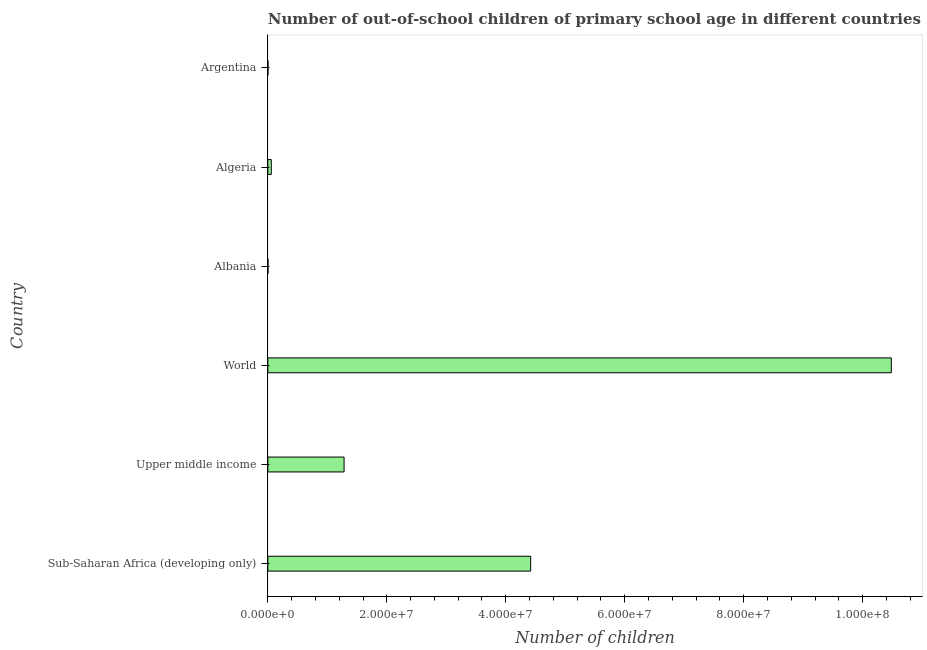What is the title of the graph?
Your answer should be compact. Number of out-of-school children of primary school age in different countries. What is the label or title of the X-axis?
Ensure brevity in your answer.  Number of children. What is the label or title of the Y-axis?
Provide a short and direct response. Country. What is the number of out-of-school children in Albania?
Offer a terse response. 1.99e+04. Across all countries, what is the maximum number of out-of-school children?
Offer a terse response. 1.05e+08. Across all countries, what is the minimum number of out-of-school children?
Your response must be concise. 1.99e+04. In which country was the number of out-of-school children maximum?
Offer a terse response. World. In which country was the number of out-of-school children minimum?
Provide a short and direct response. Albania. What is the sum of the number of out-of-school children?
Your response must be concise. 1.62e+08. What is the difference between the number of out-of-school children in Sub-Saharan Africa (developing only) and Upper middle income?
Keep it short and to the point. 3.14e+07. What is the average number of out-of-school children per country?
Keep it short and to the point. 2.71e+07. What is the median number of out-of-school children?
Provide a short and direct response. 6.70e+06. What is the ratio of the number of out-of-school children in Argentina to that in World?
Keep it short and to the point. 0. Is the difference between the number of out-of-school children in Sub-Saharan Africa (developing only) and Upper middle income greater than the difference between any two countries?
Your response must be concise. No. What is the difference between the highest and the second highest number of out-of-school children?
Ensure brevity in your answer.  6.06e+07. What is the difference between the highest and the lowest number of out-of-school children?
Offer a very short reply. 1.05e+08. In how many countries, is the number of out-of-school children greater than the average number of out-of-school children taken over all countries?
Your response must be concise. 2. How many countries are there in the graph?
Your answer should be compact. 6. Are the values on the major ticks of X-axis written in scientific E-notation?
Provide a succinct answer. Yes. What is the Number of children of Sub-Saharan Africa (developing only)?
Make the answer very short. 4.42e+07. What is the Number of children of Upper middle income?
Give a very brief answer. 1.28e+07. What is the Number of children in World?
Make the answer very short. 1.05e+08. What is the Number of children in Albania?
Your answer should be compact. 1.99e+04. What is the Number of children of Algeria?
Keep it short and to the point. 5.78e+05. What is the Number of children of Argentina?
Keep it short and to the point. 2.34e+04. What is the difference between the Number of children in Sub-Saharan Africa (developing only) and Upper middle income?
Your answer should be compact. 3.14e+07. What is the difference between the Number of children in Sub-Saharan Africa (developing only) and World?
Give a very brief answer. -6.06e+07. What is the difference between the Number of children in Sub-Saharan Africa (developing only) and Albania?
Provide a short and direct response. 4.42e+07. What is the difference between the Number of children in Sub-Saharan Africa (developing only) and Algeria?
Your answer should be compact. 4.36e+07. What is the difference between the Number of children in Sub-Saharan Africa (developing only) and Argentina?
Your response must be concise. 4.42e+07. What is the difference between the Number of children in Upper middle income and World?
Your answer should be very brief. -9.20e+07. What is the difference between the Number of children in Upper middle income and Albania?
Your answer should be compact. 1.28e+07. What is the difference between the Number of children in Upper middle income and Algeria?
Provide a short and direct response. 1.22e+07. What is the difference between the Number of children in Upper middle income and Argentina?
Your answer should be compact. 1.28e+07. What is the difference between the Number of children in World and Albania?
Keep it short and to the point. 1.05e+08. What is the difference between the Number of children in World and Algeria?
Your answer should be compact. 1.04e+08. What is the difference between the Number of children in World and Argentina?
Offer a very short reply. 1.05e+08. What is the difference between the Number of children in Albania and Algeria?
Offer a terse response. -5.58e+05. What is the difference between the Number of children in Albania and Argentina?
Keep it short and to the point. -3591. What is the difference between the Number of children in Algeria and Argentina?
Your response must be concise. 5.54e+05. What is the ratio of the Number of children in Sub-Saharan Africa (developing only) to that in Upper middle income?
Provide a succinct answer. 3.45. What is the ratio of the Number of children in Sub-Saharan Africa (developing only) to that in World?
Make the answer very short. 0.42. What is the ratio of the Number of children in Sub-Saharan Africa (developing only) to that in Albania?
Ensure brevity in your answer.  2225.38. What is the ratio of the Number of children in Sub-Saharan Africa (developing only) to that in Algeria?
Ensure brevity in your answer.  76.51. What is the ratio of the Number of children in Sub-Saharan Africa (developing only) to that in Argentina?
Your answer should be very brief. 1884.54. What is the ratio of the Number of children in Upper middle income to that in World?
Offer a terse response. 0.12. What is the ratio of the Number of children in Upper middle income to that in Albania?
Offer a very short reply. 645.48. What is the ratio of the Number of children in Upper middle income to that in Algeria?
Make the answer very short. 22.19. What is the ratio of the Number of children in Upper middle income to that in Argentina?
Your answer should be compact. 546.62. What is the ratio of the Number of children in World to that in Albania?
Your answer should be compact. 5279.32. What is the ratio of the Number of children in World to that in Algeria?
Your response must be concise. 181.51. What is the ratio of the Number of children in World to that in Argentina?
Give a very brief answer. 4470.74. What is the ratio of the Number of children in Albania to that in Algeria?
Give a very brief answer. 0.03. What is the ratio of the Number of children in Albania to that in Argentina?
Keep it short and to the point. 0.85. What is the ratio of the Number of children in Algeria to that in Argentina?
Make the answer very short. 24.63. 